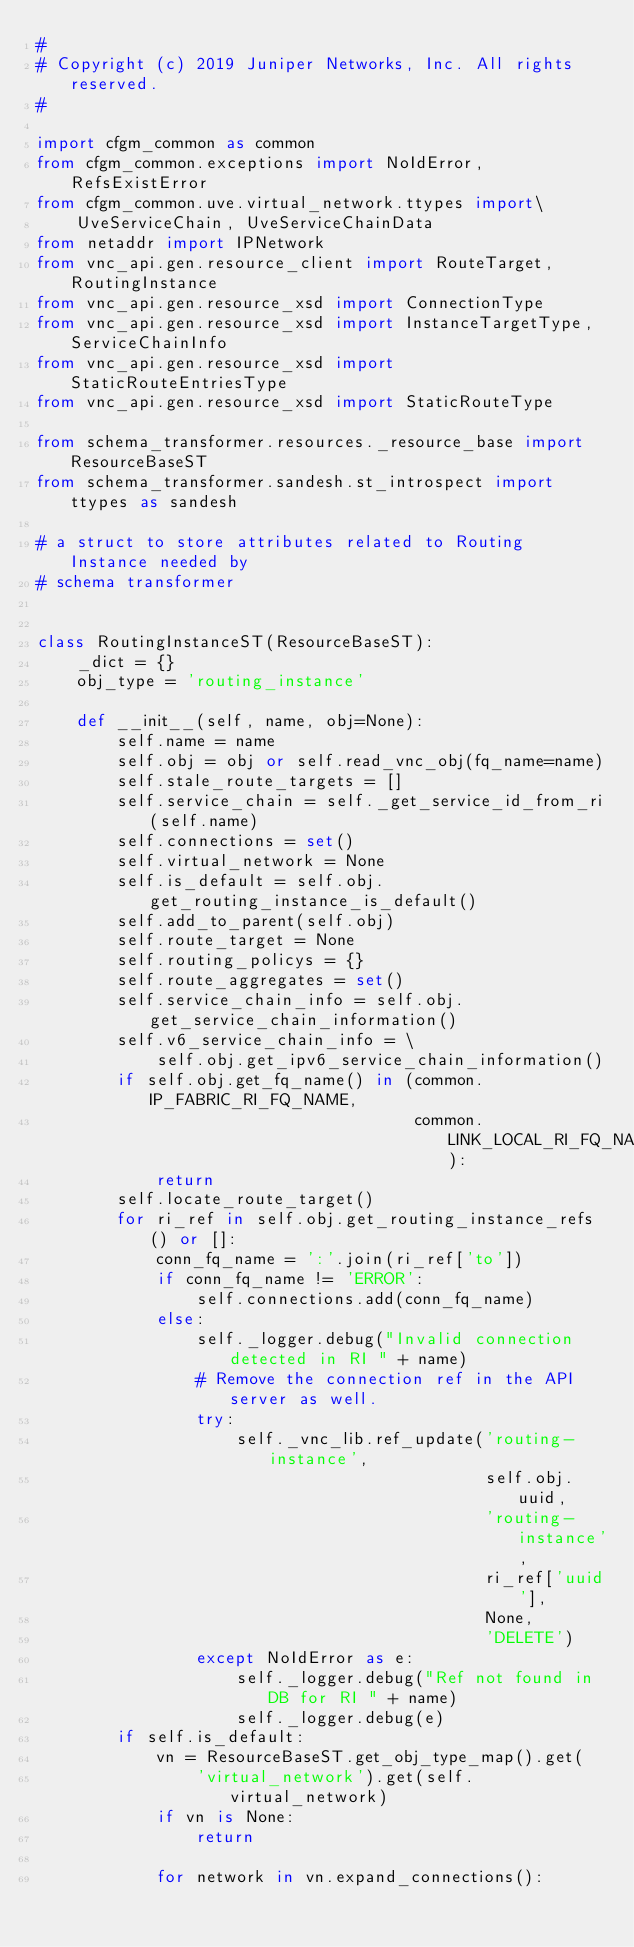Convert code to text. <code><loc_0><loc_0><loc_500><loc_500><_Python_>#
# Copyright (c) 2019 Juniper Networks, Inc. All rights reserved.
#

import cfgm_common as common
from cfgm_common.exceptions import NoIdError, RefsExistError
from cfgm_common.uve.virtual_network.ttypes import\
    UveServiceChain, UveServiceChainData
from netaddr import IPNetwork
from vnc_api.gen.resource_client import RouteTarget, RoutingInstance
from vnc_api.gen.resource_xsd import ConnectionType
from vnc_api.gen.resource_xsd import InstanceTargetType, ServiceChainInfo
from vnc_api.gen.resource_xsd import StaticRouteEntriesType
from vnc_api.gen.resource_xsd import StaticRouteType

from schema_transformer.resources._resource_base import ResourceBaseST
from schema_transformer.sandesh.st_introspect import ttypes as sandesh

# a struct to store attributes related to Routing Instance needed by
# schema transformer


class RoutingInstanceST(ResourceBaseST):
    _dict = {}
    obj_type = 'routing_instance'

    def __init__(self, name, obj=None):
        self.name = name
        self.obj = obj or self.read_vnc_obj(fq_name=name)
        self.stale_route_targets = []
        self.service_chain = self._get_service_id_from_ri(self.name)
        self.connections = set()
        self.virtual_network = None
        self.is_default = self.obj.get_routing_instance_is_default()
        self.add_to_parent(self.obj)
        self.route_target = None
        self.routing_policys = {}
        self.route_aggregates = set()
        self.service_chain_info = self.obj.get_service_chain_information()
        self.v6_service_chain_info = \
            self.obj.get_ipv6_service_chain_information()
        if self.obj.get_fq_name() in (common.IP_FABRIC_RI_FQ_NAME,
                                      common.LINK_LOCAL_RI_FQ_NAME):
            return
        self.locate_route_target()
        for ri_ref in self.obj.get_routing_instance_refs() or []:
            conn_fq_name = ':'.join(ri_ref['to'])
            if conn_fq_name != 'ERROR':
                self.connections.add(conn_fq_name)
            else:
                self._logger.debug("Invalid connection detected in RI " + name)
                # Remove the connection ref in the API server as well.
                try:
                    self._vnc_lib.ref_update('routing-instance',
                                             self.obj.uuid,
                                             'routing-instance',
                                             ri_ref['uuid'],
                                             None,
                                             'DELETE')
                except NoIdError as e:
                    self._logger.debug("Ref not found in DB for RI " + name)
                    self._logger.debug(e)
        if self.is_default:
            vn = ResourceBaseST.get_obj_type_map().get(
                'virtual_network').get(self.virtual_network)
            if vn is None:
                return

            for network in vn.expand_connections():</code> 